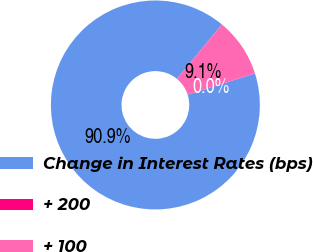Convert chart to OTSL. <chart><loc_0><loc_0><loc_500><loc_500><pie_chart><fcel>Change in Interest Rates (bps)<fcel>+ 200<fcel>+ 100<nl><fcel>90.87%<fcel>0.02%<fcel>9.11%<nl></chart> 